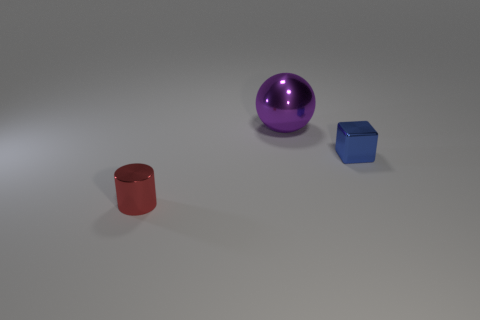Add 1 small purple matte spheres. How many objects exist? 4 Subtract all spheres. How many objects are left? 2 Add 3 large purple shiny balls. How many large purple shiny balls exist? 4 Subtract 1 purple spheres. How many objects are left? 2 Subtract all cubes. Subtract all shiny cylinders. How many objects are left? 1 Add 2 tiny objects. How many tiny objects are left? 4 